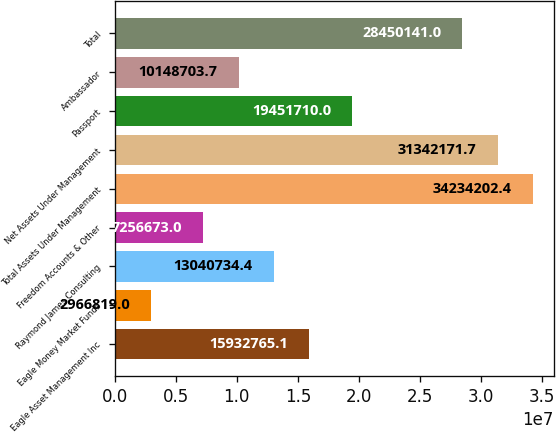Convert chart to OTSL. <chart><loc_0><loc_0><loc_500><loc_500><bar_chart><fcel>Eagle Asset Management Inc<fcel>Eagle Money Market Funds<fcel>Raymond James Consulting<fcel>Freedom Accounts & Other<fcel>Total Assets Under Management<fcel>Net Assets Under Management<fcel>Passport<fcel>Ambassador<fcel>Total<nl><fcel>1.59328e+07<fcel>2.96682e+06<fcel>1.30407e+07<fcel>7.25667e+06<fcel>3.42342e+07<fcel>3.13422e+07<fcel>1.94517e+07<fcel>1.01487e+07<fcel>2.84501e+07<nl></chart> 